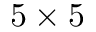<formula> <loc_0><loc_0><loc_500><loc_500>5 \times 5</formula> 